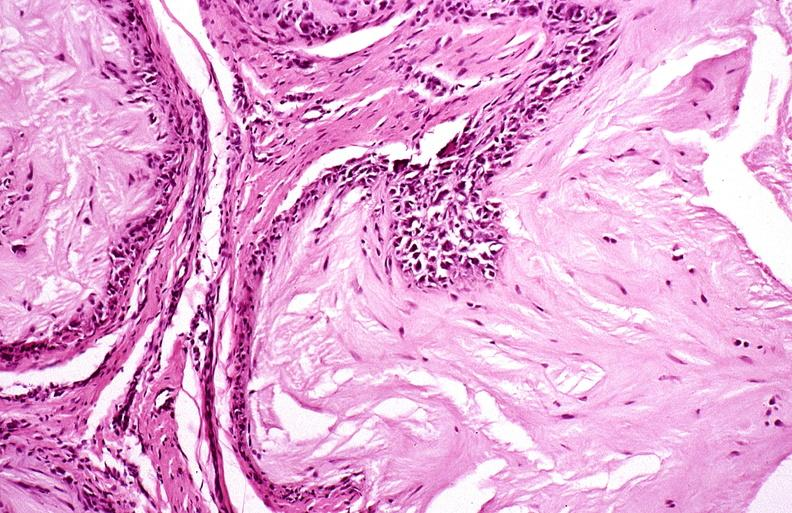does pinworm show gout?
Answer the question using a single word or phrase. No 